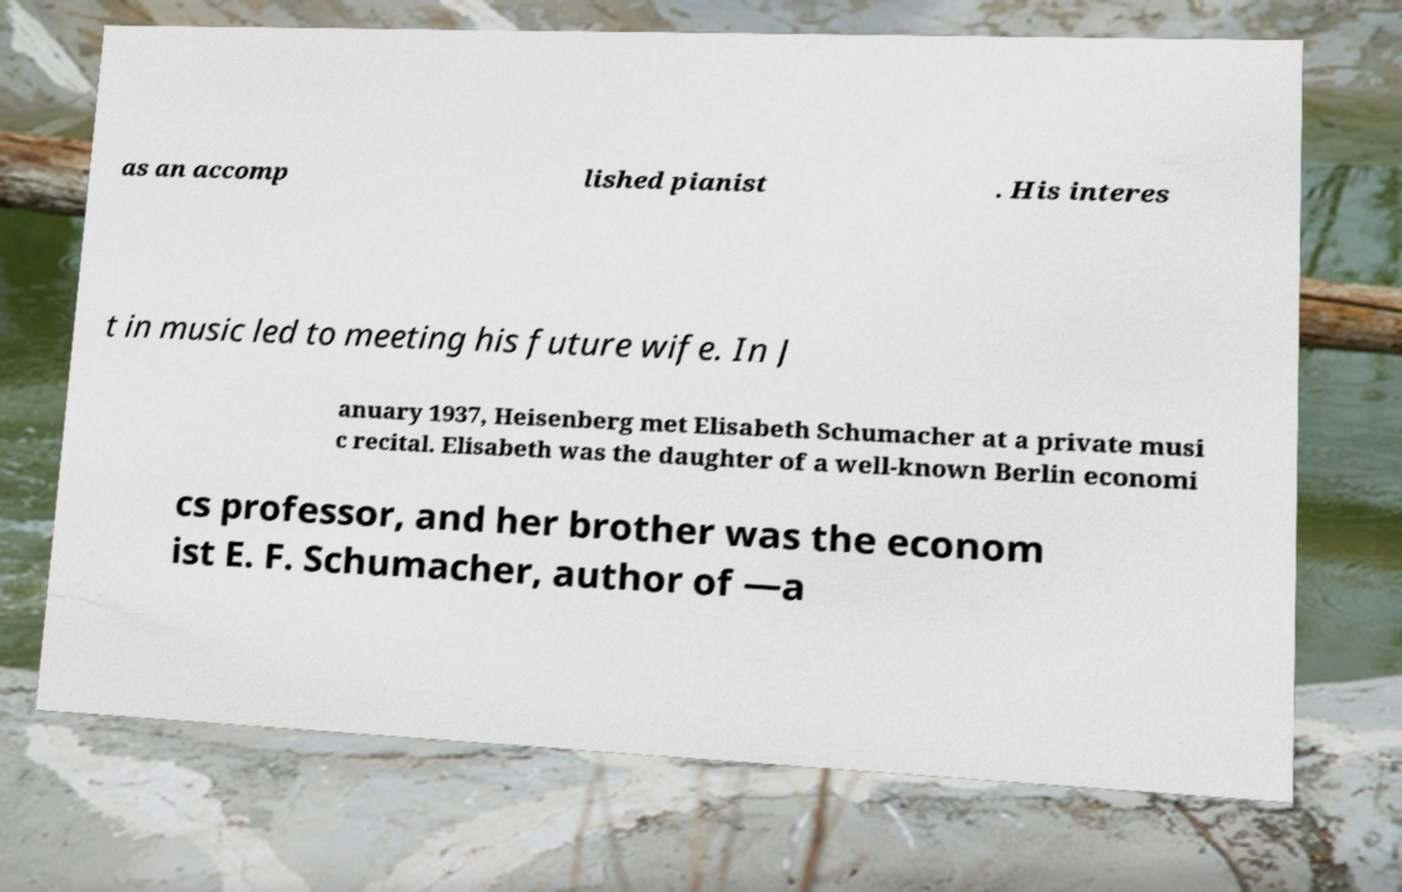Could you assist in decoding the text presented in this image and type it out clearly? as an accomp lished pianist . His interes t in music led to meeting his future wife. In J anuary 1937, Heisenberg met Elisabeth Schumacher at a private musi c recital. Elisabeth was the daughter of a well-known Berlin economi cs professor, and her brother was the econom ist E. F. Schumacher, author of —a 